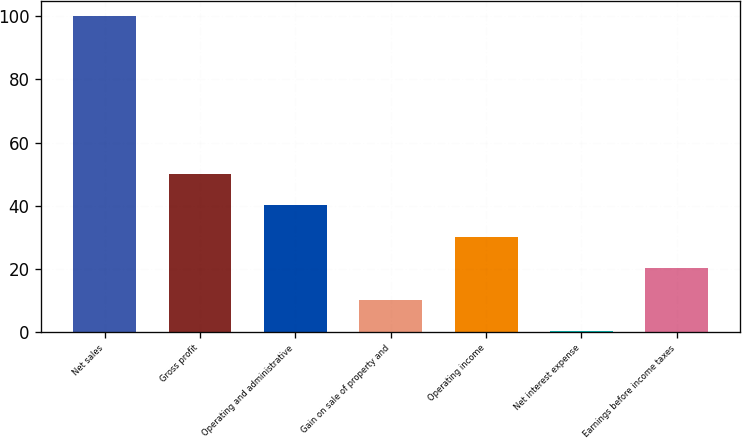Convert chart to OTSL. <chart><loc_0><loc_0><loc_500><loc_500><bar_chart><fcel>Net sales<fcel>Gross profit<fcel>Operating and administrative<fcel>Gain on sale of property and<fcel>Operating income<fcel>Net interest expense<fcel>Earnings before income taxes<nl><fcel>100<fcel>50.1<fcel>40.12<fcel>10.18<fcel>30.14<fcel>0.2<fcel>20.16<nl></chart> 